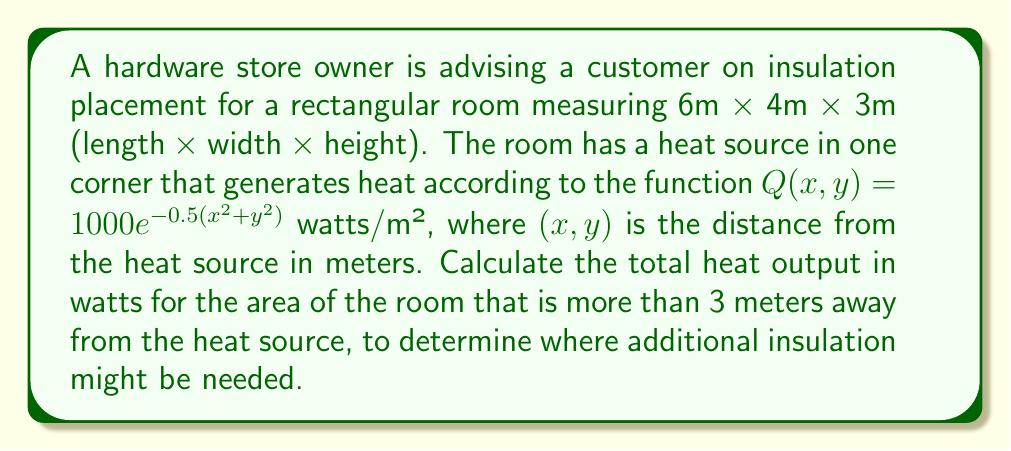Provide a solution to this math problem. To solve this problem, we'll follow these steps:

1) First, we need to set up the double integral to calculate the heat output over the required area. The integral will be:

   $$ Q_{total} = \int\int_{R} Q(x,y) \, dA $$

   where R is the region of the room that is more than 3 meters away from the heat source.

2) The heat source is in one corner, so we can place our origin there. The region R can be described in polar coordinates as $r > 3$, where $r = \sqrt{x^2 + y^2}$.

3) We need to change our integral to polar coordinates:

   $$ Q_{total} = \int_{0}^{\arctan(4/6)} \int_{3}^{\sqrt{36+16}} 1000e^{-0.5r^2} r \, dr \, d\theta $$

4) The limits of $\theta$ go from 0 to $\arctan(4/6)$ because that's the angle of the room's diagonal from the corner.

5) The upper limit of r is $\sqrt{36+16} = \sqrt{52}$ because that's the length of the room's diagonal.

6) Now we can evaluate the inner integral:

   $$ Q_{total} = 1000 \int_{0}^{\arctan(4/6)} [-e^{-0.5r^2}]_{3}^{\sqrt{52}} \, d\theta $$

7) Evaluating this:

   $$ Q_{total} = 1000 \int_{0}^{\arctan(4/6)} (e^{-0.5(3^2)} - e^{-0.5(52)}) \, d\theta $$

8) The result of the inner integral is constant with respect to $\theta$, so we can simply multiply by the outer integral's limits:

   $$ Q_{total} = 1000 \cdot \arctan(4/6) \cdot (e^{-4.5} - e^{-26}) $$

9) Evaluating this numerically:

   $$ Q_{total} \approx 1000 \cdot 0.5880 \cdot (0.0111 - 5.3762 \times 10^{-12}) \approx 6.53 \text{ watts} $$
Answer: 6.53 watts 